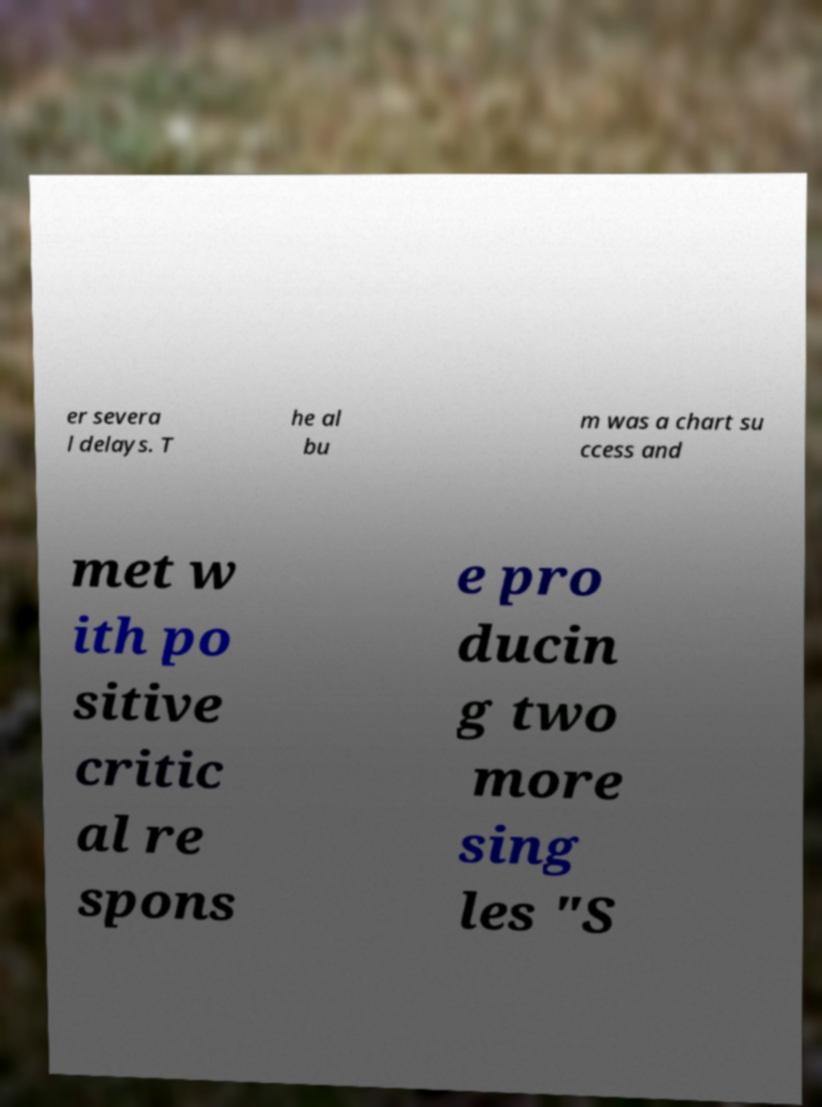For documentation purposes, I need the text within this image transcribed. Could you provide that? er severa l delays. T he al bu m was a chart su ccess and met w ith po sitive critic al re spons e pro ducin g two more sing les "S 